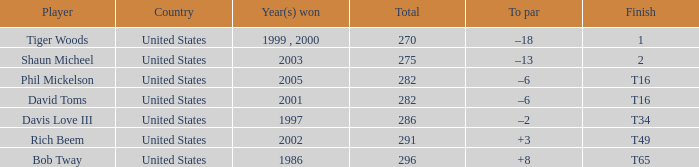In what year(s) did the individual with a total of 291 victories achieve them? 2002.0. 